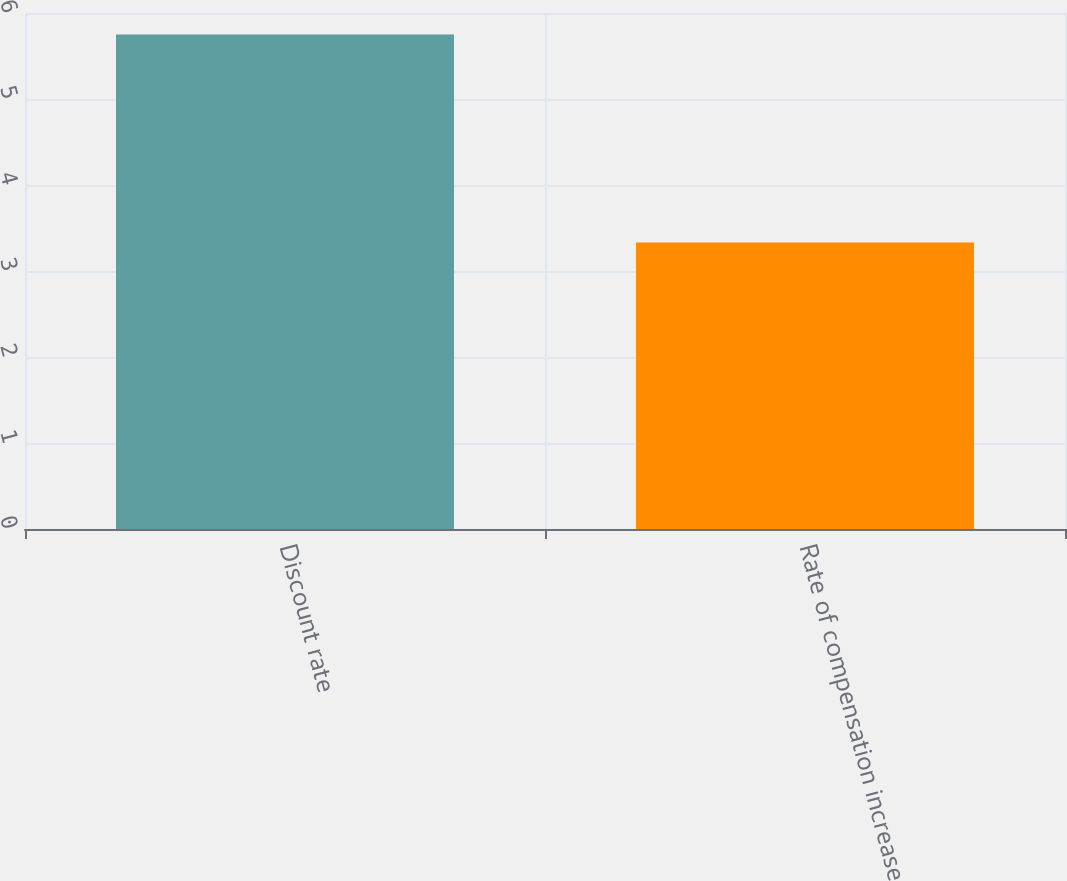Convert chart to OTSL. <chart><loc_0><loc_0><loc_500><loc_500><bar_chart><fcel>Discount rate<fcel>Rate of compensation increase<nl><fcel>5.75<fcel>3.33<nl></chart> 